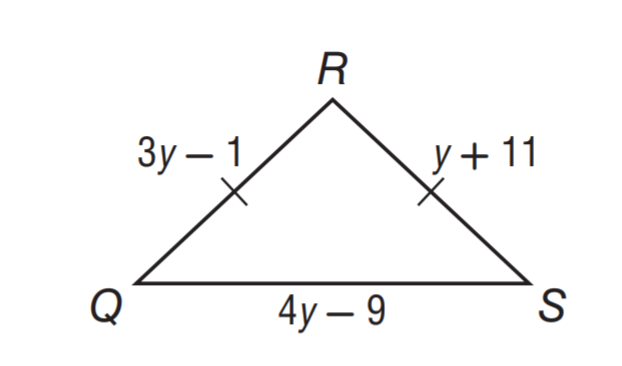Question: Find y.
Choices:
A. 4
B. 6
C. 8
D. 14
Answer with the letter. Answer: B 